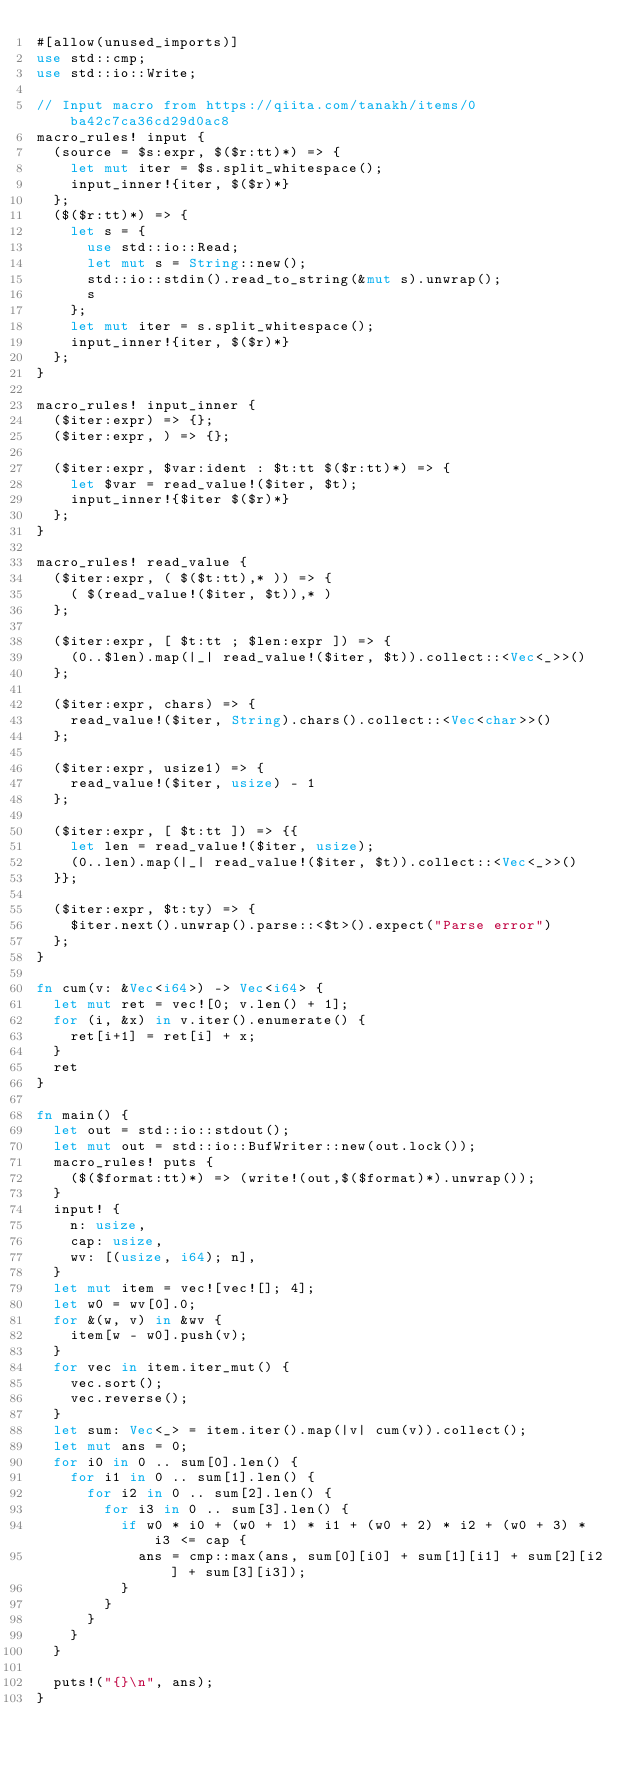Convert code to text. <code><loc_0><loc_0><loc_500><loc_500><_Rust_>#[allow(unused_imports)]
use std::cmp;
use std::io::Write;

// Input macro from https://qiita.com/tanakh/items/0ba42c7ca36cd29d0ac8
macro_rules! input {
  (source = $s:expr, $($r:tt)*) => {
    let mut iter = $s.split_whitespace();
    input_inner!{iter, $($r)*}
  };
  ($($r:tt)*) => {
    let s = {
      use std::io::Read;
      let mut s = String::new();
      std::io::stdin().read_to_string(&mut s).unwrap();
      s
    };
    let mut iter = s.split_whitespace();
    input_inner!{iter, $($r)*}
  };
}

macro_rules! input_inner {
  ($iter:expr) => {};
  ($iter:expr, ) => {};

  ($iter:expr, $var:ident : $t:tt $($r:tt)*) => {
    let $var = read_value!($iter, $t);
    input_inner!{$iter $($r)*}
  };
}

macro_rules! read_value {
  ($iter:expr, ( $($t:tt),* )) => {
    ( $(read_value!($iter, $t)),* )
  };

  ($iter:expr, [ $t:tt ; $len:expr ]) => {
    (0..$len).map(|_| read_value!($iter, $t)).collect::<Vec<_>>()
  };

  ($iter:expr, chars) => {
    read_value!($iter, String).chars().collect::<Vec<char>>()
  };

  ($iter:expr, usize1) => {
    read_value!($iter, usize) - 1
  };

  ($iter:expr, [ $t:tt ]) => {{
    let len = read_value!($iter, usize);
    (0..len).map(|_| read_value!($iter, $t)).collect::<Vec<_>>()
  }};

  ($iter:expr, $t:ty) => {
    $iter.next().unwrap().parse::<$t>().expect("Parse error")
  };
}

fn cum(v: &Vec<i64>) -> Vec<i64> {
  let mut ret = vec![0; v.len() + 1];
  for (i, &x) in v.iter().enumerate() {
    ret[i+1] = ret[i] + x;
  }
  ret
}

fn main() {
  let out = std::io::stdout();
  let mut out = std::io::BufWriter::new(out.lock());
  macro_rules! puts {
    ($($format:tt)*) => (write!(out,$($format)*).unwrap());
  }
  input! {
    n: usize,
    cap: usize,
    wv: [(usize, i64); n],
  }
  let mut item = vec![vec![]; 4];
  let w0 = wv[0].0;
  for &(w, v) in &wv {
    item[w - w0].push(v);
  }
  for vec in item.iter_mut() {
    vec.sort();
    vec.reverse();
  }
  let sum: Vec<_> = item.iter().map(|v| cum(v)).collect();
  let mut ans = 0;
  for i0 in 0 .. sum[0].len() {
    for i1 in 0 .. sum[1].len() {
      for i2 in 0 .. sum[2].len() {
        for i3 in 0 .. sum[3].len() {
          if w0 * i0 + (w0 + 1) * i1 + (w0 + 2) * i2 + (w0 + 3) * i3 <= cap {
            ans = cmp::max(ans, sum[0][i0] + sum[1][i1] + sum[2][i2] + sum[3][i3]);
          }
        }
      }
    }
  }

  puts!("{}\n", ans);
}
</code> 